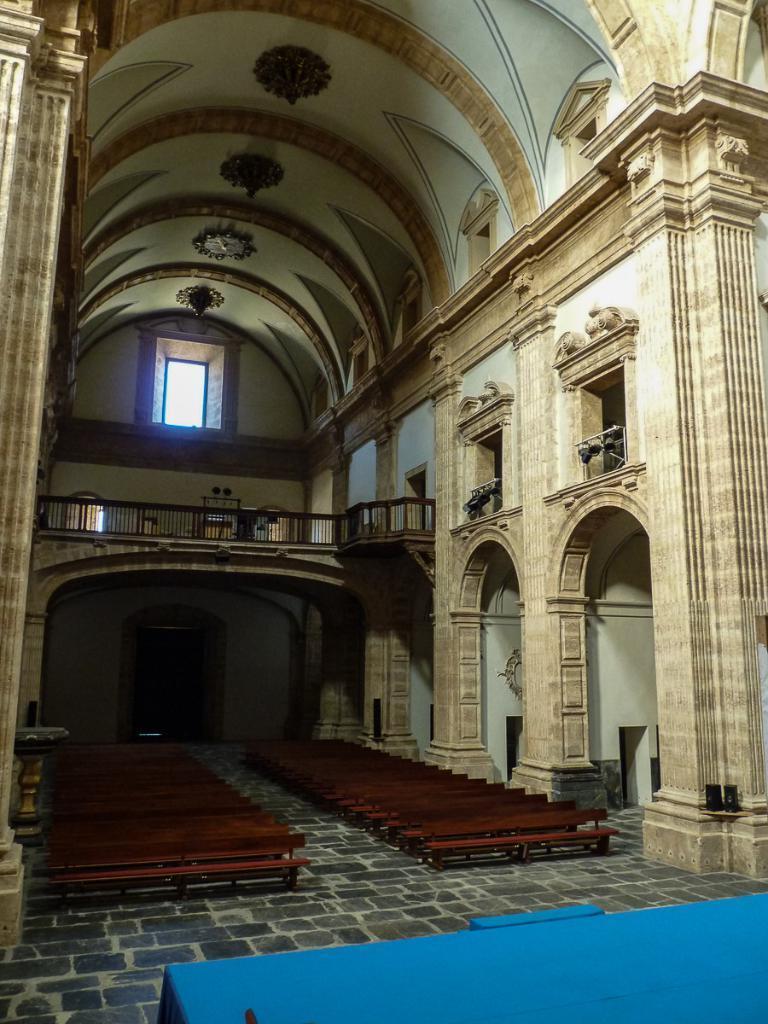Please provide a concise description of this image. In this image we can see the interiors of a building which consists of benches, railings, lights and a few other objects, there is architecture designs on its walls. 